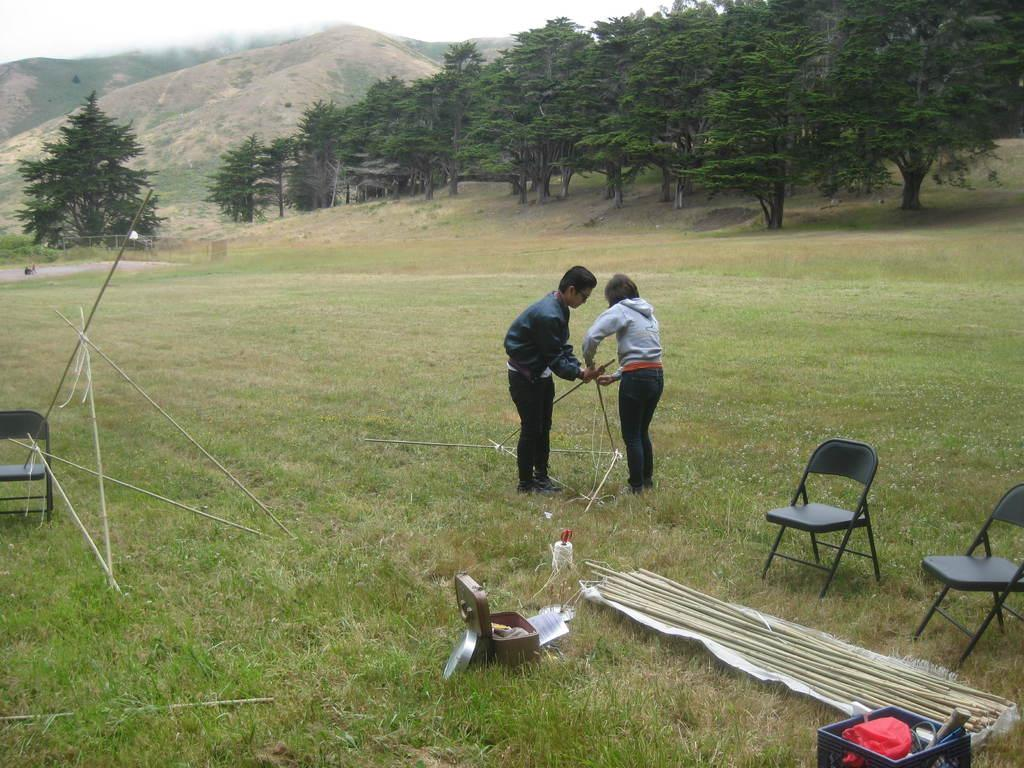How many people are in the image? There are 2 people in the image. What are the people holding in the image? The people are holding wooden poles. Where are the people standing in the image? The people are standing on a grass field. What type of vegetation can be seen in the image? Trees are visible in the image. What type of geographical feature is present in the image? Mountains are present in the image. What is the weight limit for the wooden poles in the image? There is no information about the weight limit for the wooden poles in the image. 